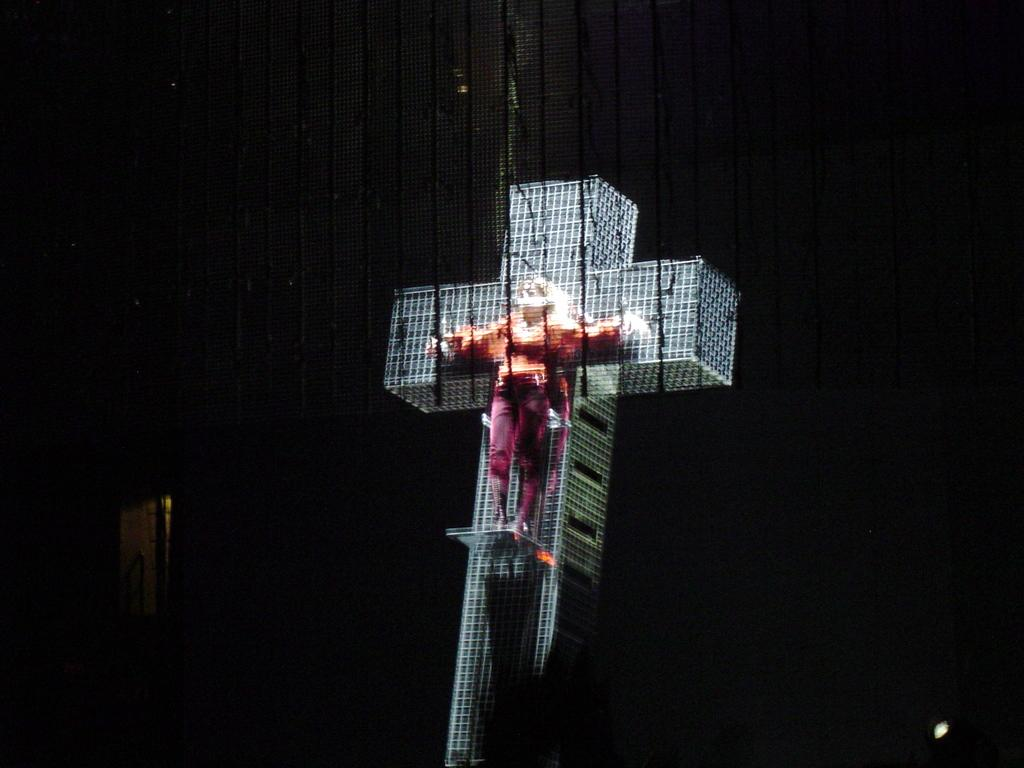What is the person in the image doing? The person is standing on a building. What type of building is it? The building has a cross symbol, which suggests it might be a church or religious building. What can be seen on the left side of the image? There is a door on the left side of the image. What type of development is taking place on the island in the image? There is no island present in the image; it features a person standing on a building with a cross symbol. 